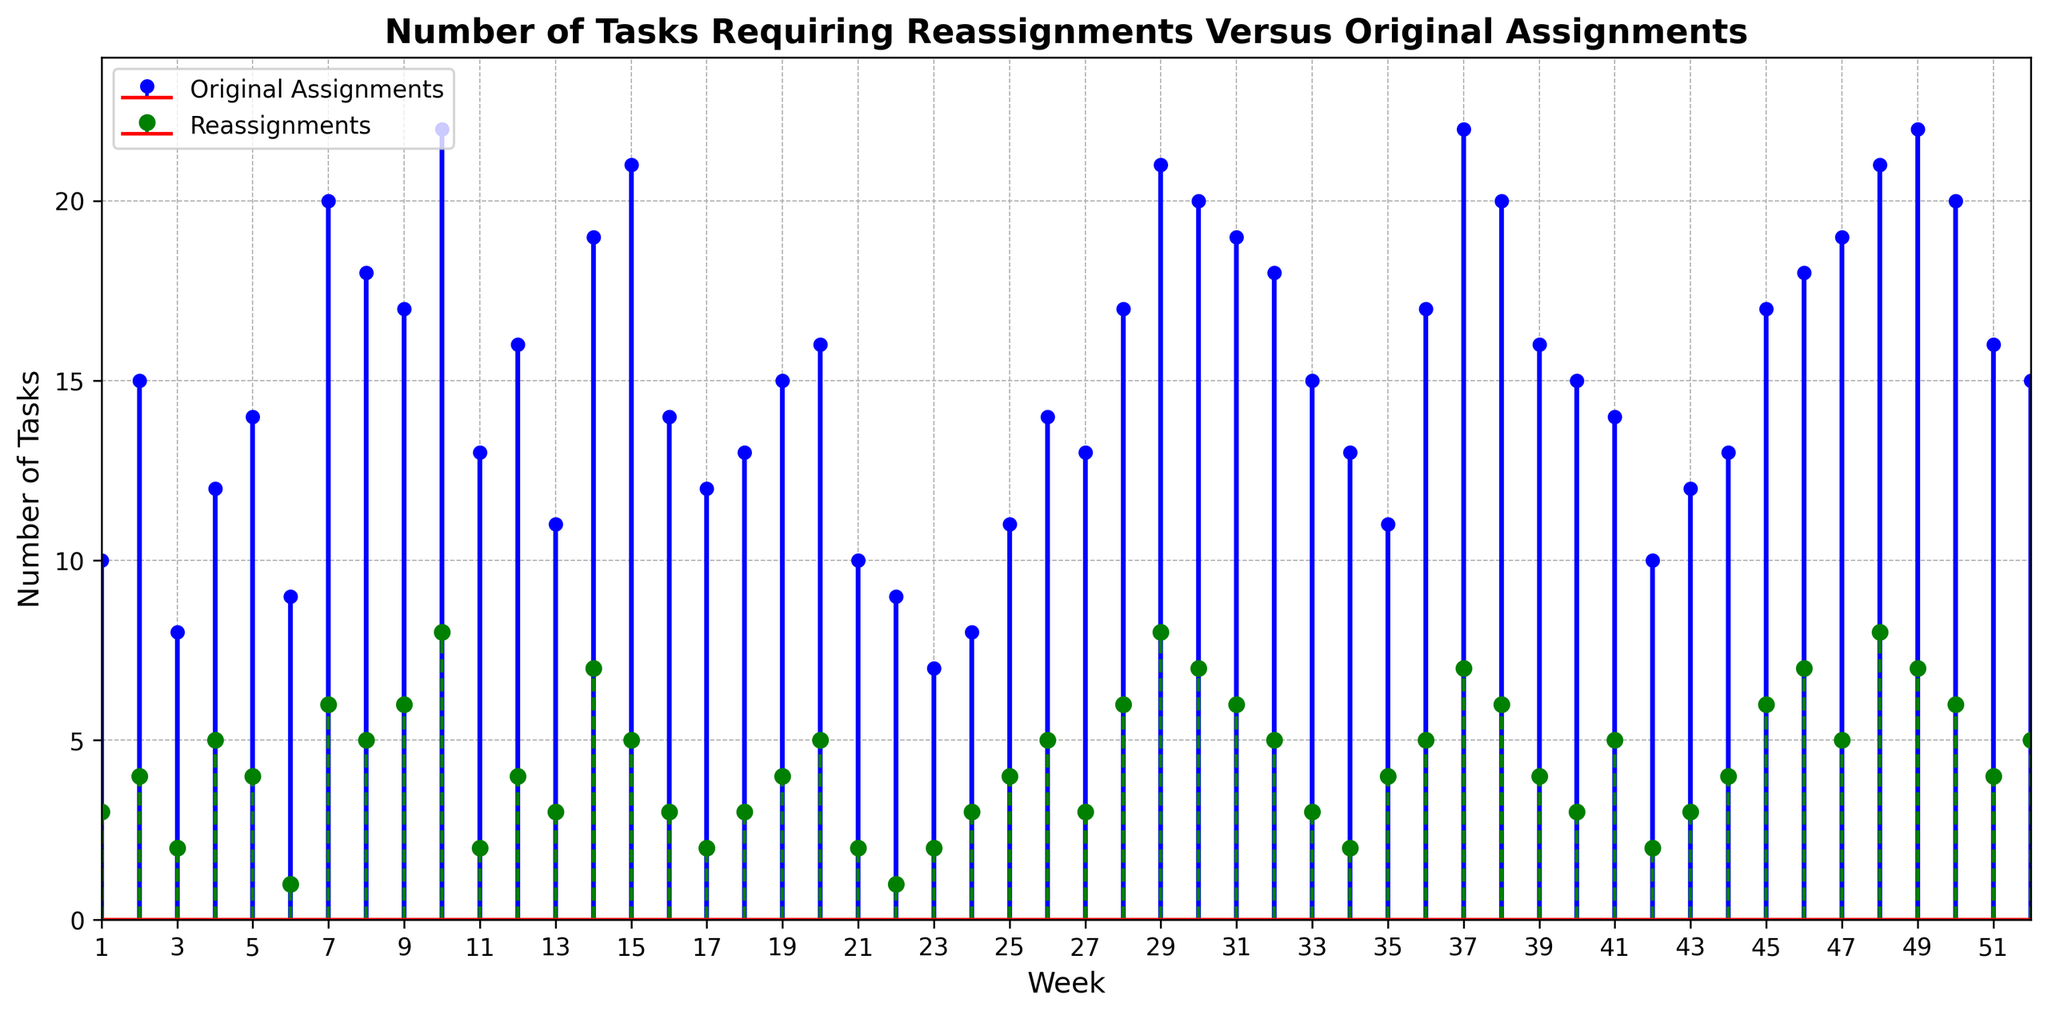How many weeks had exactly 4 reassignments? To determine this, identify the weeks where the number of reassignments is 4 from the plot. There are weeks 2, 5, 12, 19, 25, 35, 39, and 52, making 8 weeks in total.
Answer: 8 Which week had the highest number of original assignments? Look for the week with the tallest blue stem for original assignments. Week 10 has the highest number of original assignments at 22.
Answer: Week 10 What is the difference between the number of original assignments and reassignments in week 30? Find the blue and green stems for week 30. The original assignments are 20, and the reassignments are 7. The difference is 20 - 7 = 13.
Answer: 13 Which week had the same number of reassignments as week 41? Find the green stem for week 41, which is 5 reassignments. Identify other weeks with green stems that are 5. These weeks are 8, 20, 26, 32, and 41. Therefore, week 41 has the same number as weeks 8, 20, 26, and 32.
Answer: Weeks 8, 20, 26, 32 How many total tasks (original + reassignments) were there in week 15? Find the blue and green stems for week 15. The original assignments are 21, and the reassignments are 5. The total is 21 + 5 = 26.
Answer: 26 What is the maximum number of reassignments in any week? Look for the tallest green stem. The tallest among all weeks is 8, which occurs in weeks 10, 29, and 48.
Answer: 8 In which weeks did the number of reassignments equal half of the original assignments? Check where the green stem is approximately half the height of the blue stem. Weeks 6 (original=9, reassignments=1) and 22 (original=9, reassignments=1) fit this condition.
Answer: Weeks 6, 22 What is the average number of original assignments in the first 4 weeks? Add the blue stem values for the first 4 weeks: 10, 15, 8, and 12. The total is 10 + 15 + 8 + 12 = 45. The average is 45 / 4 = 11.25.
Answer: 11.25 Describe the trend of the number of reassignments over the year. Observe the pattern of the green stems. They generally fluctuate but show a slight increasing trend towards the middle and later part of the year. This indicates that reassignments tend to be slightly higher towards year-end.
Answer: Slightly increasing trend towards year-end Compare the number of reassignments in week 37 with week 38. Which is higher? Identify the green stems for weeks 37 and 38. Week 37 has 7 reassignments, and week 38 has 6. Therefore, reassignments are higher in week 37.
Answer: Week 37 